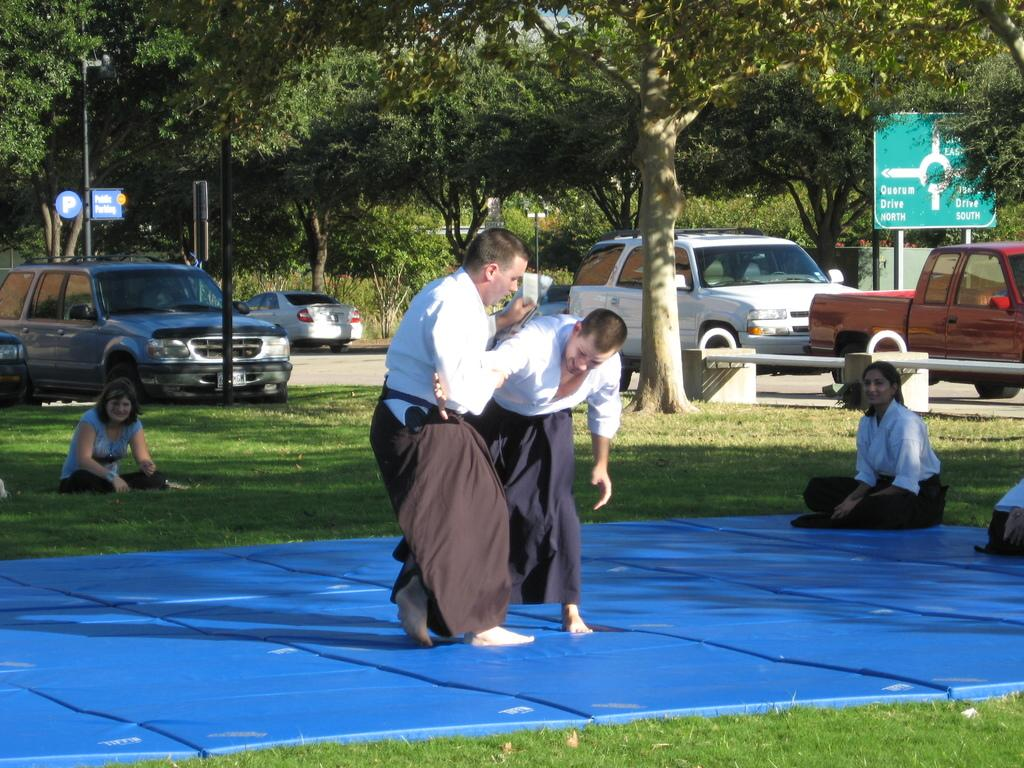How many people are in the image? There are people in the image, but the exact number is not specified. What type of flooring is present in the image? There are tatami mats in the image. What type of natural environment is visible in the image? There is grass in the image. What type of man-made structure is visible in the image? There is a road in the image. What type of transportation is present in the image? There are vehicles in the image. What type of seating is present in the image? There is a bench in the image. What type of plant container is present in the image? There is a planter in the image. What type of vertical structures are present in the image? There are poles in the image. What type of flat, board-like structures are present in the image? There are boards in the image. What type of tall, natural structures are present in the image? There are trees in the image. What type of worm can be seen crawling on the bench in the image? There is no worm present in the image; only people, tatami mats, grass, a road, vehicles, a bench, a planter, poles, boards, and trees are visible. What type of idea is being discussed by the people in the image? The image does not provide any information about the people's conversation or ideas. 